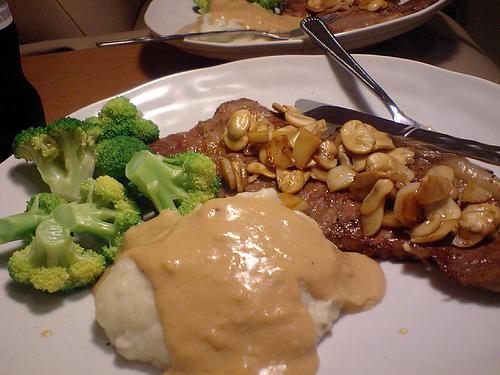What is covered in gravy?
Concise answer only. Mashed potatoes. How many plates are there?
Answer briefly. 2. What is the green stuff called?
Quick response, please. Broccoli. Is this a European dish?
Write a very short answer. No. What is the meat?
Keep it brief. Beef. What is the protein on the plate?
Answer briefly. Steak. What color is the plate?
Keep it brief. White. 